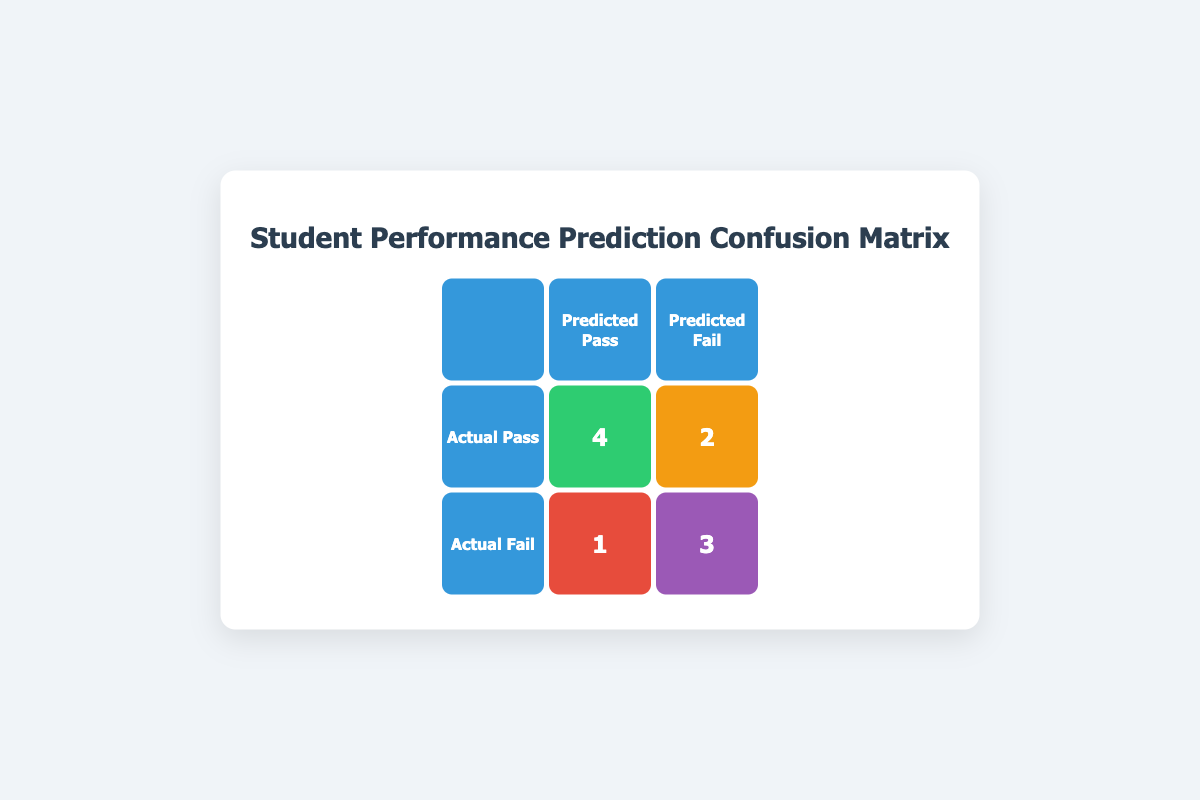What is the value for true positives in the confusion matrix? The true positives, represented by the green cell in the table, indicate the count of students who actually passed and were correctly predicted to pass. The value located here is 4.
Answer: 4 How many students were predicted to fail? To find the total number of students predicted to fail, we can look at the two cells under the "Predicted Fail" column. There are 2 students who actually passed and were predicted to fail (false negatives) and 3 students who actually failed and were correctly predicted to fail (true negatives), giving a total of 2 + 3 = 5 students predicted to fail.
Answer: 5 What is the number of false negatives? The false negatives are found by identifying the students who actually passed but were predicted to fail. According to the table, this value is located in the corresponding cell, which shows 2 students.
Answer: 2 Is the number of true negatives greater than the number of false positives? We can look at the respective values in the confusion matrix. The true negatives are 3, while the false positives are 1. Since 3 is greater than 1, the answer is yes.
Answer: Yes What is the total count of students who passed according to the actual performance? To obtain the count of students who passed, we need to sum the true positives and false negatives. The total is calculated as 4 (true positives) + 2 (false negatives) = 6, meaning 6 students passed according to the actual performance.
Answer: 6 If 10 students were assessed, what percentage passed based on the actual performance? We already identified that 6 out of the 10 students passed. To find the percentage, we divide the number of students who passed (6) by the total number of students (10) and then multiply by 100. The calculation is (6/10) * 100 = 60%. Therefore, 60% of the students passed based on actual performance.
Answer: 60% What is the difference in the number of true positives and true negatives? The true positives are 4 and the true negatives are 3. To find the difference, we subtract the true negatives from the true positives: 4 - 3 = 1. Thus, the difference is 1.
Answer: 1 How many students correctly passed according to their predicted performance? The students who correctly passed according to their predicted performance are counted by the true positives, which is 4 as per the confusion matrix.
Answer: 4 